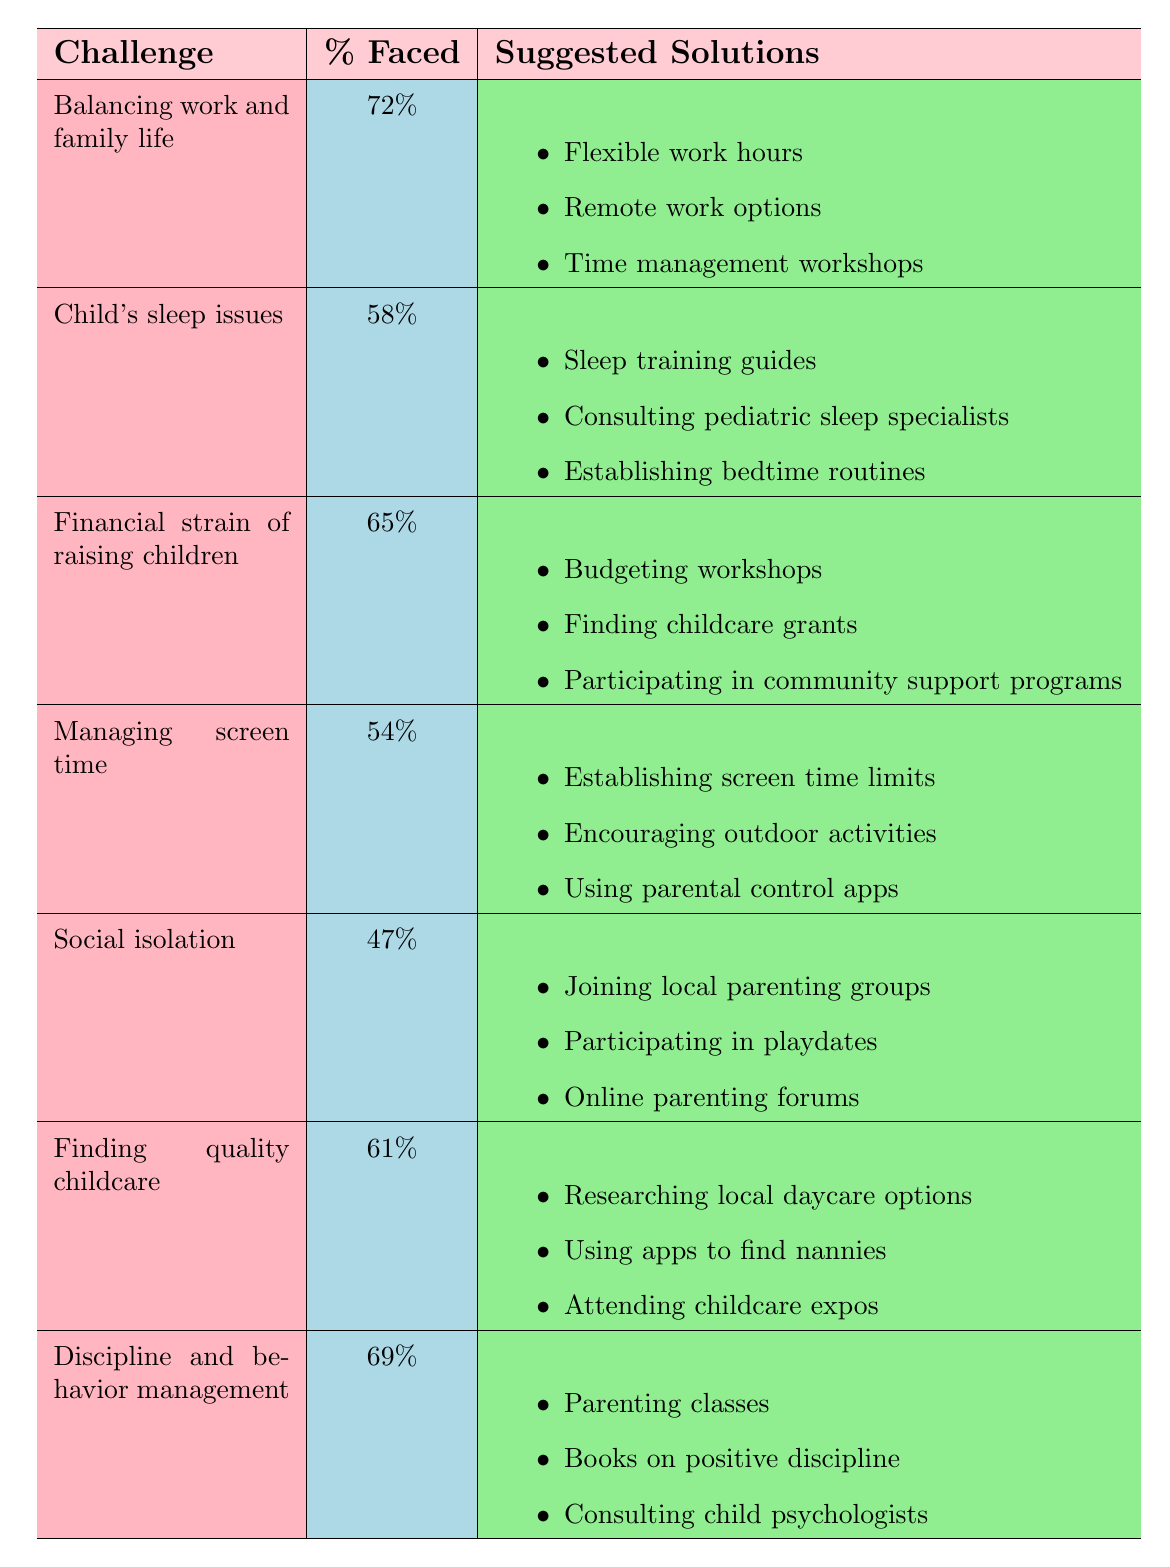What is the percentage of mothers facing the challenge of balancing work and family life? The table states that the percentage faced for the challenge of balancing work and family life is listed as 72%.
Answer: 72% Which parenting challenge has the highest percentage faced? By looking at the percentages in the table, "Balancing work and family life" has the highest percentage at 72%.
Answer: Balancing work and family life What solutions are suggested for managing screen time? According to the table, the solutions for managing screen time are: Establishing screen time limits, Encouraging outdoor activities, and Using parental control apps.
Answer: Establishing screen time limits, Encouraging outdoor activities, Using parental control apps What is the average percentage faced across all listed challenges? To find the average, sum all percentages: 72 + 58 + 65 + 54 + 47 + 61 + 69 = 446. There are 7 challenges, so the average is 446 / 7 = 63.71.
Answer: 63.71 Is the percentage of mothers facing social isolation higher than those facing child's sleep issues? From the table, the percentage for social isolation is 47% and for child's sleep issues is 58%. Since 47% is not higher than 58%, the answer is no.
Answer: No How many challenges have a percentage faced of 60% or above? Analyzing the table, the challenges with 60% or above are: Balancing work and family life (72%), Financial strain of raising children (65%), Finding quality childcare (61%), and Discipline and behavior management (69%). This totals to 4 challenges.
Answer: 4 What is the difference in percentage faced between the challenge of finding quality childcare and social isolation? The percentage faced for finding quality childcare is 61% and for social isolation is 47%. The difference is 61 - 47 = 14.
Answer: 14 Which challenge has fewer mothers facing it: managing screen time or social isolation? The table lists managing screen time at 54% and social isolation at 47%. Since 47% (social isolation) is fewer than 54% (managing screen time), the answer is social isolation.
Answer: Social isolation What percentage of mothers face financial strain of raising children and discipline issues combined? From the table, the financial strain of raising children is faced by 65% of mothers and discipline and behavior management by 69%. The combined percentage is 65 + 69 = 134%.
Answer: 134% 